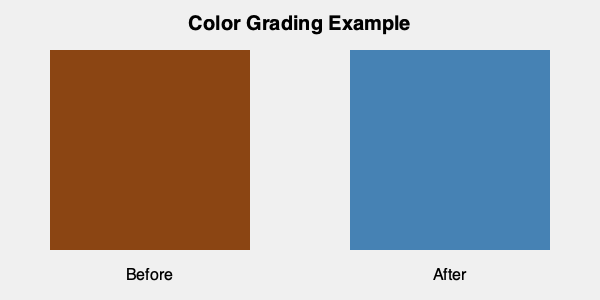In the context of creating contrasting moods through color grading, analyze the before-and-after images provided. How does the shift from warm to cool tones impact the emotional response of the audience, and how might this technique be used to enhance narrative tension in a high-stakes action sequence? To answer this question, let's break down the color grading process and its impact:

1. Color Analysis:
   - Before image: Dominated by warm tones (brown, #8B4513)
   - After image: Shifted to cool tones (steel blue, #4682B4)

2. Emotional Impact:
   - Warm tones (before): Generally associated with comfort, intimacy, and nostalgia
   - Cool tones (after): Often evoke feelings of detachment, mystery, or tension

3. Narrative Enhancement:
   - The shift from warm to cool can signify a change in the story's mood or atmosphere
   - In a high-stakes action sequence, this transition could represent:
     a) A move from a safe environment to a dangerous one
     b) A character's emotional journey from confidence to uncertainty
     c) An increase in overall tension or suspense

4. Audience Response:
   - Warm tones may relax the audience, lowering their guard
   - The sudden shift to cool tones can create unease or anticipation

5. Cinematic Technique:
   - This color grading technique can be used to:
     a) Foreshadow upcoming conflicts
     b) Emphasize the gravity of a situation
     c) Create visual contrast between different story beats

6. Application in Action Sequences:
   - Start with warm tones to establish a false sense of security
   - Gradually or abruptly transition to cool tones as the action intensifies
   - Use the color shift to amplify the impact of plot twists or sudden dangers

By employing this color grading technique, a director can manipulate the audience's emotional state without relying solely on dialogue or explicit visual cues, thereby enhancing the overall storytelling and creating a more immersive experience.
Answer: The shift from warm to cool tones creates tension and unease, enhancing narrative intensity in action sequences by visually signaling danger and emotional shifts. 